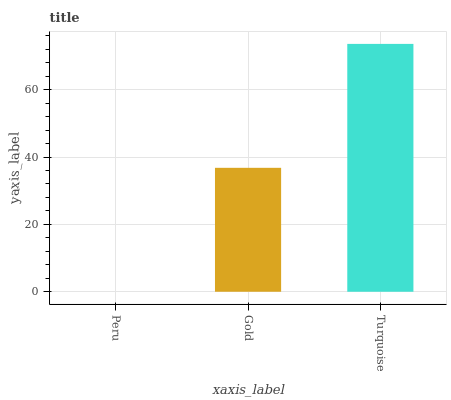Is Peru the minimum?
Answer yes or no. Yes. Is Turquoise the maximum?
Answer yes or no. Yes. Is Gold the minimum?
Answer yes or no. No. Is Gold the maximum?
Answer yes or no. No. Is Gold greater than Peru?
Answer yes or no. Yes. Is Peru less than Gold?
Answer yes or no. Yes. Is Peru greater than Gold?
Answer yes or no. No. Is Gold less than Peru?
Answer yes or no. No. Is Gold the high median?
Answer yes or no. Yes. Is Gold the low median?
Answer yes or no. Yes. Is Turquoise the high median?
Answer yes or no. No. Is Turquoise the low median?
Answer yes or no. No. 